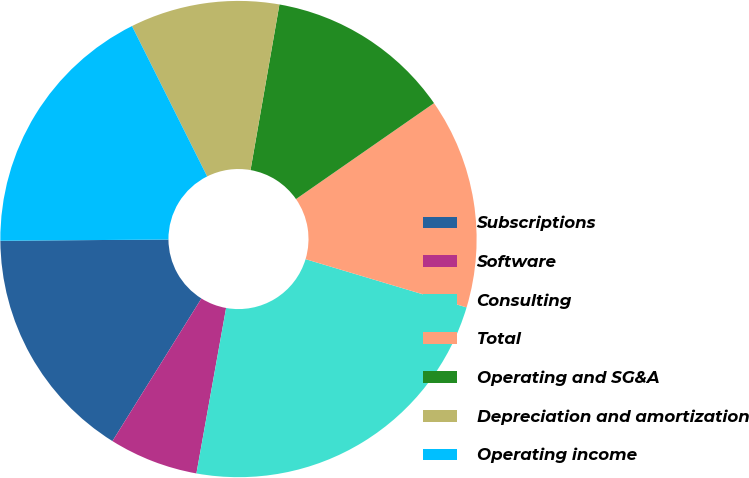Convert chart. <chart><loc_0><loc_0><loc_500><loc_500><pie_chart><fcel>Subscriptions<fcel>Software<fcel>Consulting<fcel>Total<fcel>Operating and SG&A<fcel>Depreciation and amortization<fcel>Operating income<nl><fcel>16.01%<fcel>6.05%<fcel>23.19%<fcel>14.3%<fcel>12.58%<fcel>10.13%<fcel>17.73%<nl></chart> 